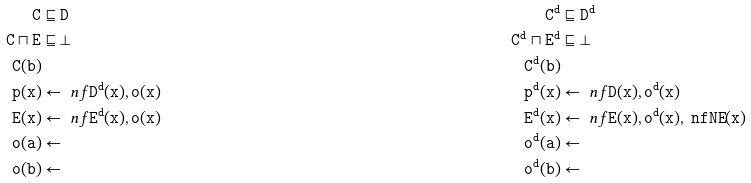Convert formula to latex. <formula><loc_0><loc_0><loc_500><loc_500>\tt { C } & \sqsubseteq \tt { D } & \tt { C ^ { d } } & \sqsubseteq \tt { D ^ { d } } \\ \tt { C } \sqcap \tt { E } & \sqsubseteq \bot & \tt { C ^ { d } } \sqcap \tt { E ^ { d } } & \sqsubseteq \bot \\ \tt { C } ( \tt { b } ) & & \tt { C ^ { d } } ( \tt { b } ) & \\ \tt { p } ( \tt { x } ) & \leftarrow \ n f \tt { D ^ { d } } ( \tt { x } ) , \tt { o } ( \tt { x } ) & \tt { p ^ { d } } ( \tt { x } ) & \leftarrow \ n f \tt { D } ( \tt { x } ) , \tt { o ^ { d } } ( \tt { x } ) \\ \tt { E } ( \tt { x } ) & \leftarrow \ n f \tt { E ^ { d } } ( \tt { x } ) , \tt { o } ( \tt { x } ) & \tt { E ^ { d } } ( \tt { x } ) & \leftarrow \ n f \tt { E } ( \tt { x } ) , \tt { o ^ { d } } ( \tt { x } ) , \ n f \tt { N E } ( x ) \\ \tt { o } ( \tt { a } ) & \leftarrow & \tt { o ^ { d } } ( \tt { a } ) & \leftarrow \\ \tt { o } ( \tt { b } ) & \leftarrow & \tt { o ^ { d } } ( \tt { b } ) & \leftarrow</formula> 